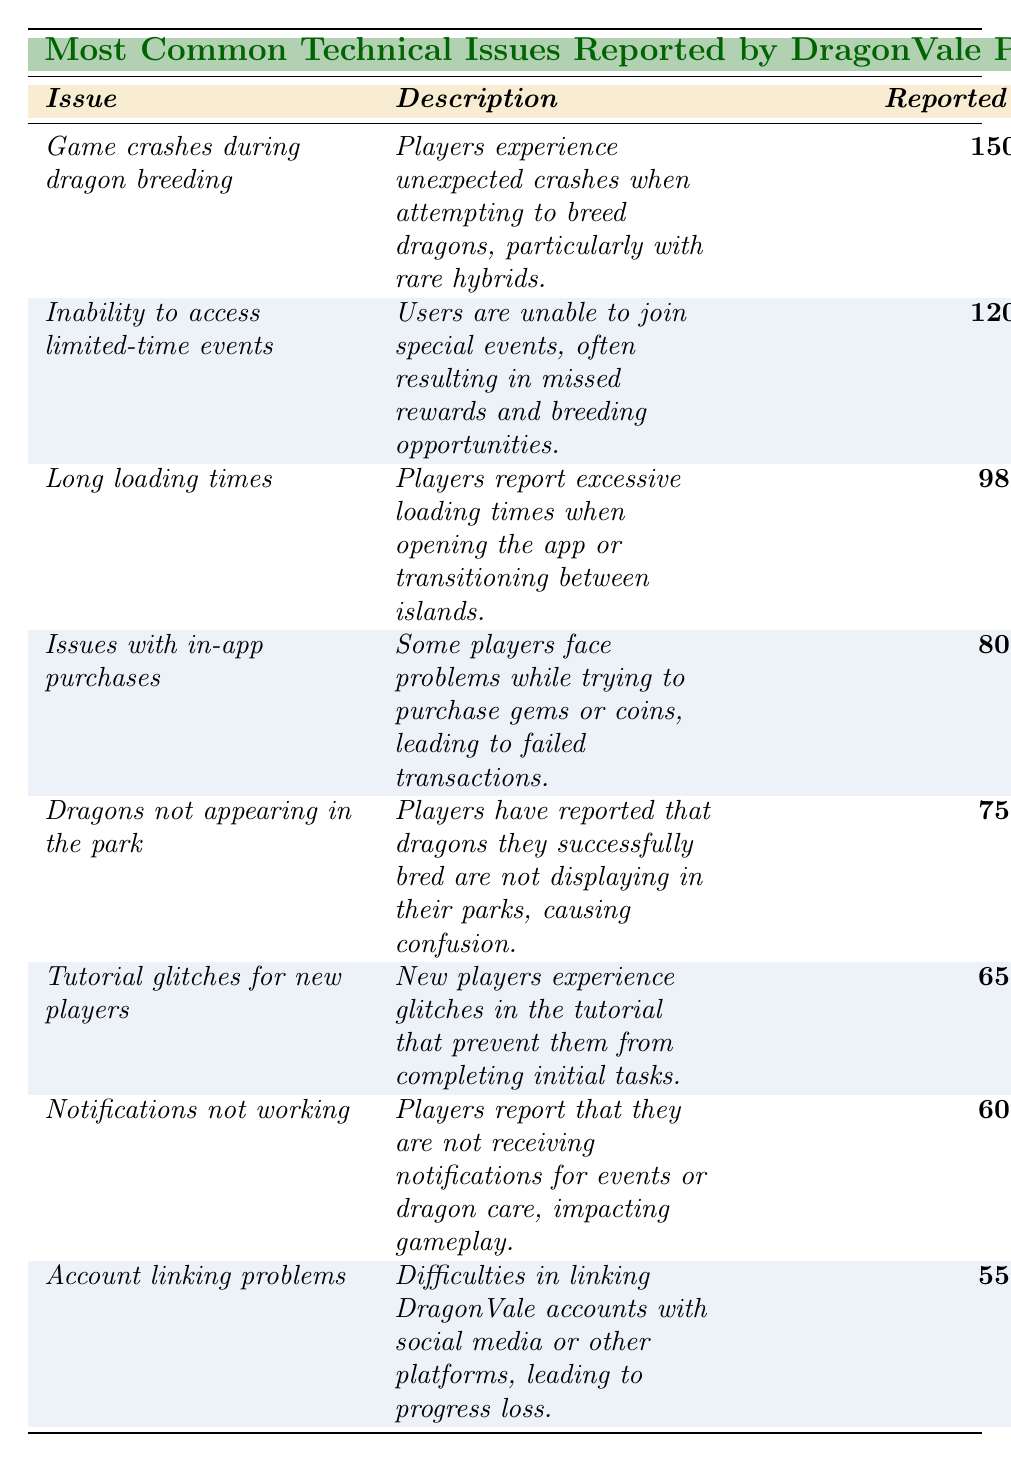What is the total number of reports for all issues combined? To find the total number of reports, we add the reported counts of each issue: 150 + 120 + 98 + 80 + 75 + 65 + 60 + 55 = 703.
Answer: 703 Which issue has the highest number of reports? The issue with the highest reported count is "Game crashes during dragon breeding," with 150 reports.
Answer: Game crashes during dragon breeding What is the reported count for "Dragons not appearing in the park"? The reported count for this issue is 75, as shown directly in the table.
Answer: 75 Is the reported count for "Account linking problems" greater than or less than 60? The reported count for "Account linking problems" is 55, which is less than 60.
Answer: Less than How many more reports did "Inability to access limited-time events" receive compared to "Tutorial glitches for new players"? We first find the reported counts for each: "Inability to access limited-time events" has 120, and "Tutorial glitches for new players" has 65. The difference is 120 - 65 = 55 reports.
Answer: 55 What is the average reported count for all issues listed in the table? To find the average, we sum all the reported counts (703) and divide by the number of issues (8): 703 / 8 = 87.875, which rounded gives us 88.
Answer: 88 Are players experiencing more issues with in-app purchases or long loading times? The reported count for in-app purchases is 80, and for long loading times, it is 98. Since 98 is greater than 80, players are facing more issues with long loading times.
Answer: More issues with long loading times What proportion of the total reports does "Issues with in-app purchases" represent? The reported count for this issue is 80. To find the proportion, we divide the count (80) by the total reports (703): 80 / 703 ≈ 0.1139, which is about 11.39%.
Answer: Approximately 11.39% 